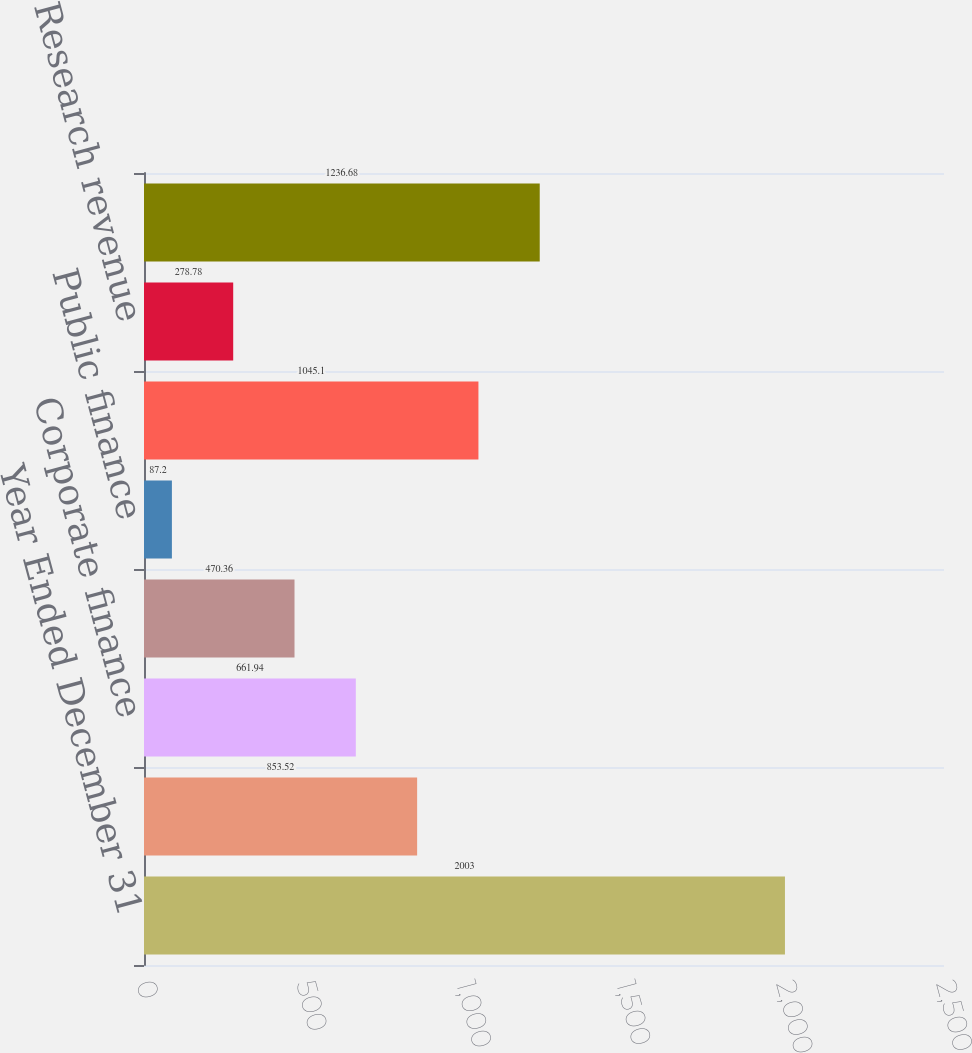Convert chart. <chart><loc_0><loc_0><loc_500><loc_500><bar_chart><fcel>Year Ended December 31<fcel>Structured finance<fcel>Corporate finance<fcel>Financial institutions and<fcel>Public finance<fcel>Total ratings revenue<fcel>Research revenue<fcel>Total Moody's Investors<nl><fcel>2003<fcel>853.52<fcel>661.94<fcel>470.36<fcel>87.2<fcel>1045.1<fcel>278.78<fcel>1236.68<nl></chart> 